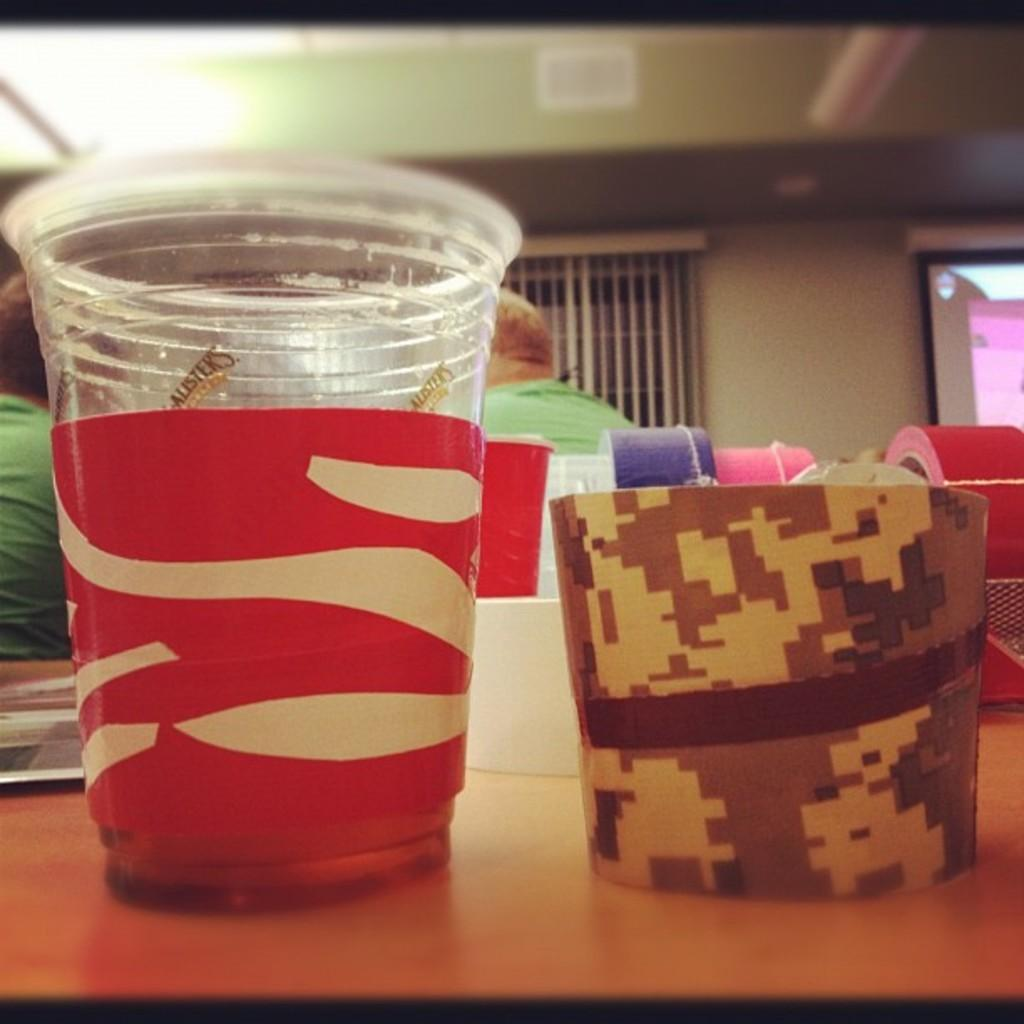What is the main object visible in the image? There is a glass in the image. What can be seen on the wooden surface in the image? There are other objects on a wooden surface in the image. What is visible in the background of the image? There are people, a wall, lights on the ceiling, and other objects visible in the background of the image. Can you tell me how many drains are visible in the image? There are no drains present in the image. What type of surprise can be seen happening in the image? There is no surprise happening in the image; it is a still scene with various objects and people in the background. 